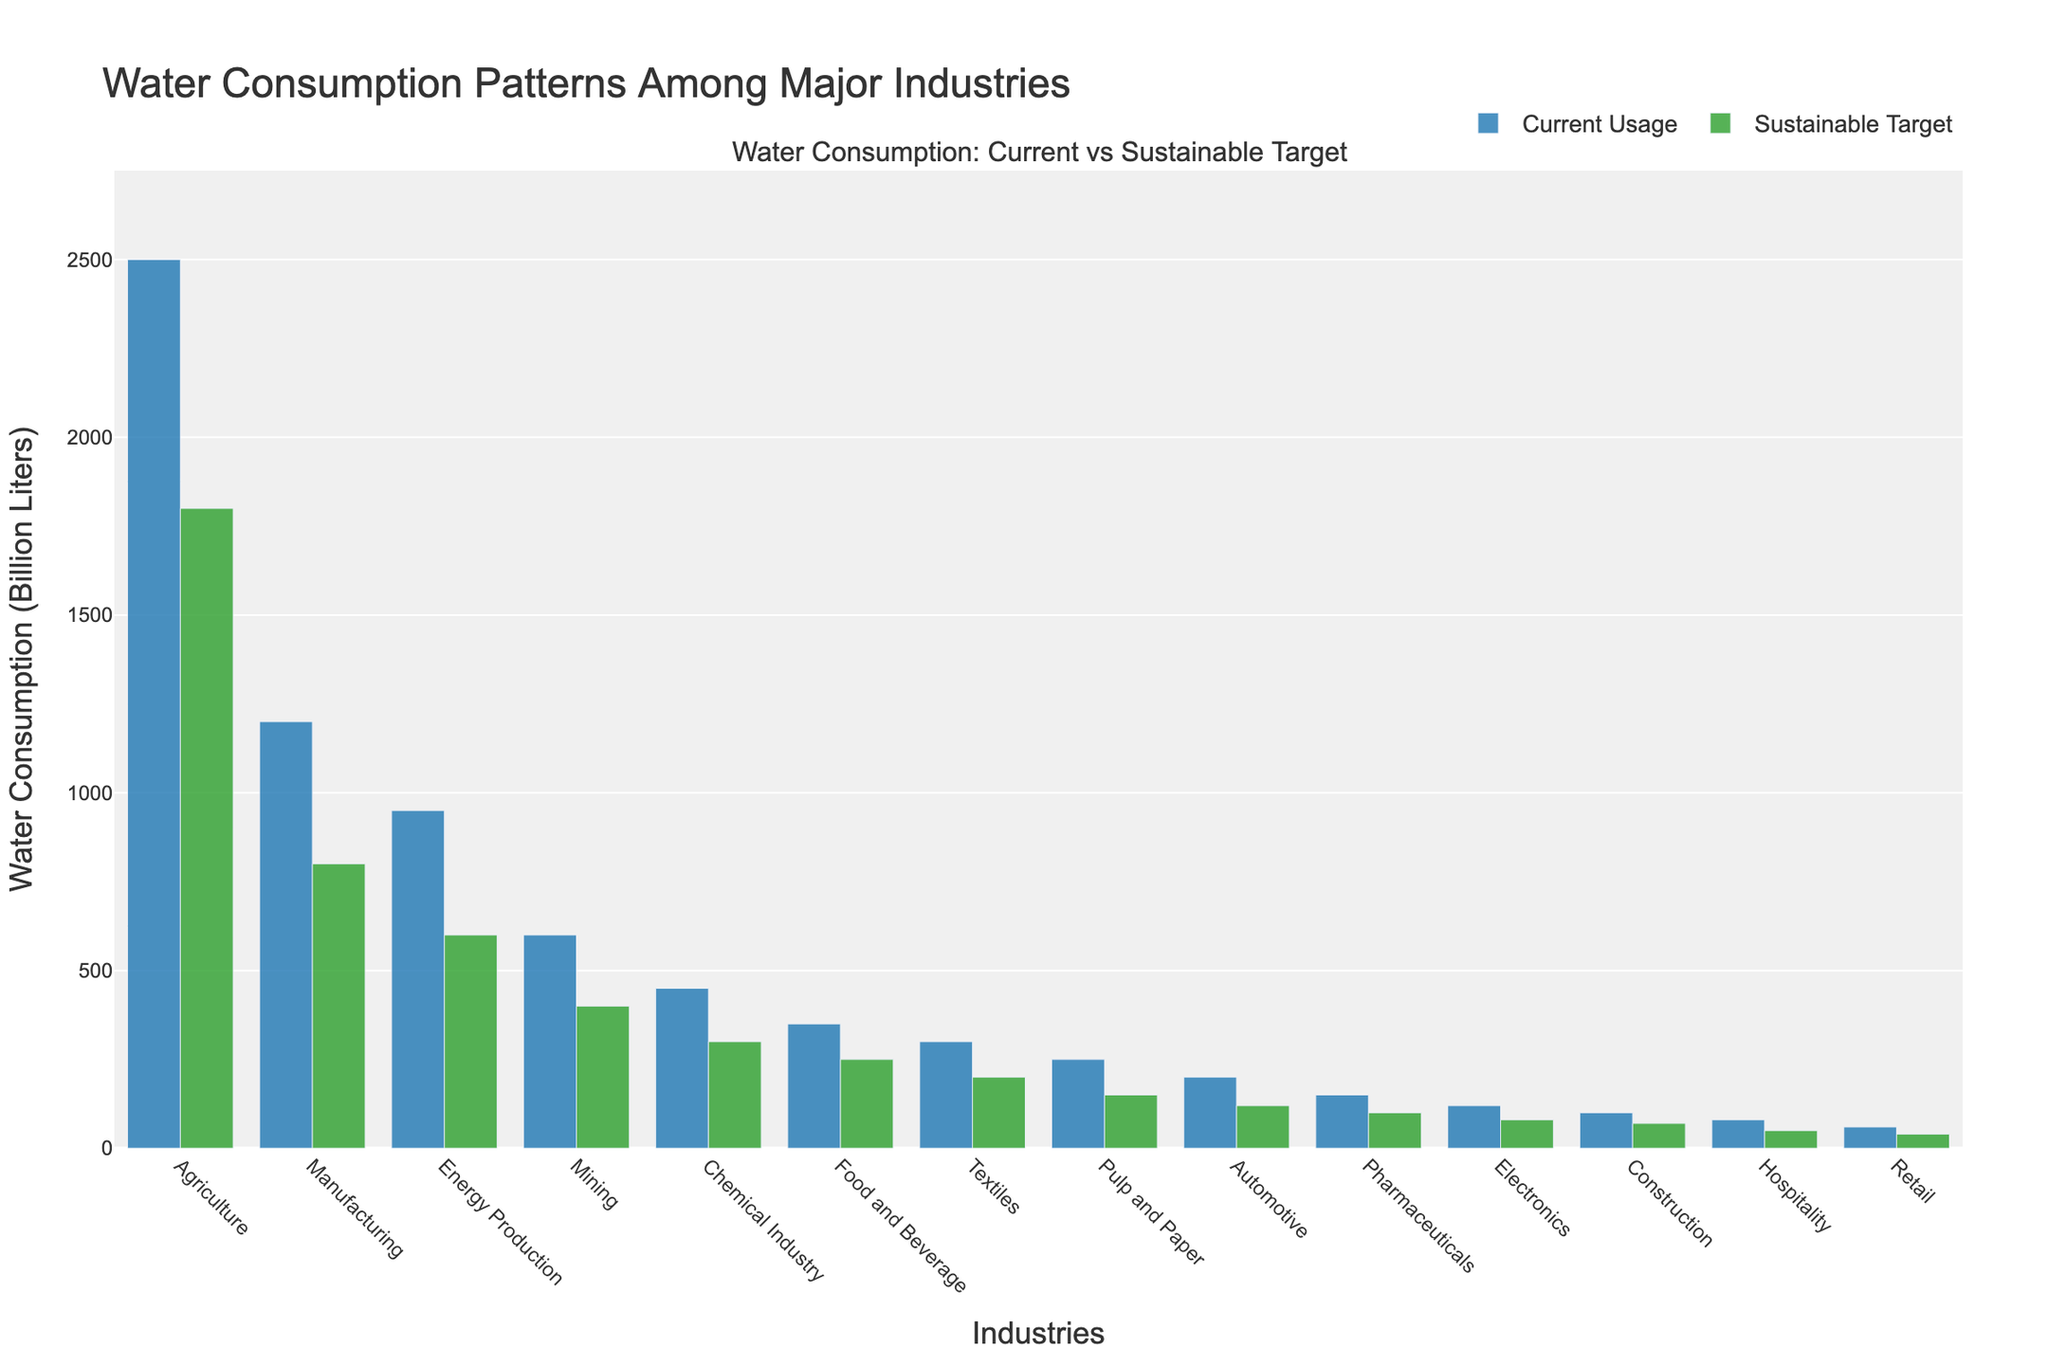What is the difference in water consumption between the Agriculture industry and the Chemical industry in the current usage? Referring to the bar heights for Agriculture and Chemical Industry for current usage, the Agriculture industry uses 2500 billion liters, and the Chemical industry uses 450 billion liters. The difference is calculated as 2500 - 450.
Answer: 2050 billion liters Which industry has the largest gap between current usage and the sustainable target? Observing the bars, the Agriculture industry has the highest current usage (2500 billion liters) and a significant difference from its sustainable target (1800 billion liters). The gap is calculated as 2500 - 1800.
Answer: Agriculture Is the current water usage of the Manufacturing industry more than twice its sustainable target? The current usage for Manufacturing is 1200 billion liters, and its sustainable target is 800 billion liters. Calculating twice the sustainable target: 2 * 800 = 1600. Comparing current usage (1200) to this value shows that it is not more than twice.
Answer: No How many industries have a current usage exceeding 500 billion liters? By visually inspecting the heights of the bars, four industries (Agriculture, Manufacturing, Energy Production, and Mining) have bars indicating current usage exceeding 500 billion liters.
Answer: 4 industries What is the total current water usage of the Food and Beverage, Textiles, and Pulp and Paper industries? Summing their current usages: Food and Beverage (350 billion liters), Textiles (300 billion liters), and Pulp and Paper (250 billion liters): 350 + 300 + 250.
Answer: 900 billion liters Which industry has the smallest sustainable target, and what is its value? The industry with the shortest bar in the Sustainable Target series is Retail, with a value of 40 billion liters.
Answer: Retail, 40 billion liters How much more water, in billion liters, does the Energy Production industry currently use compared to its sustainable target? The current usage for Energy Production is 950 billion liters, and the sustainable target is 600 billion liters. The difference is calculated as 950 - 600.
Answer: 350 billion liters 